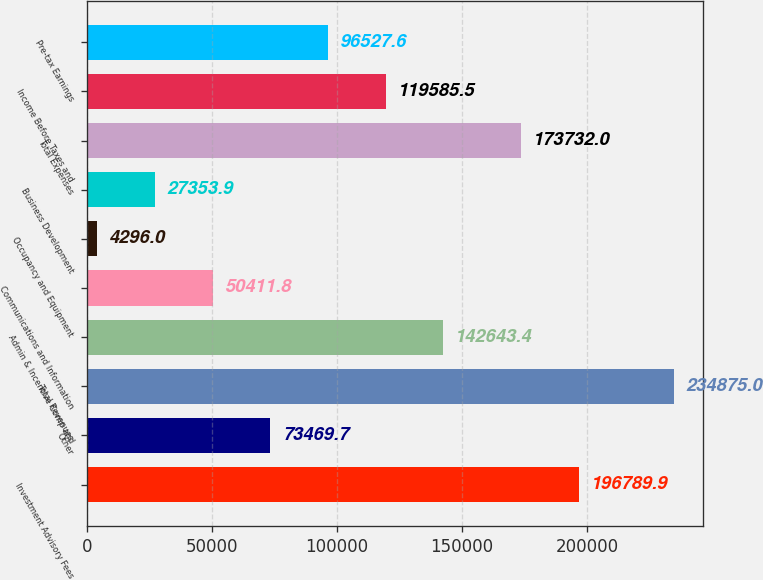<chart> <loc_0><loc_0><loc_500><loc_500><bar_chart><fcel>Investment Advisory Fees<fcel>Other<fcel>Total Revenues<fcel>Admin & Incentive Comp and<fcel>Communications and Information<fcel>Occupancy and Equipment<fcel>Business Development<fcel>Total Expenses<fcel>Income Before Taxes and<fcel>Pre-tax Earnings<nl><fcel>196790<fcel>73469.7<fcel>234875<fcel>142643<fcel>50411.8<fcel>4296<fcel>27353.9<fcel>173732<fcel>119586<fcel>96527.6<nl></chart> 